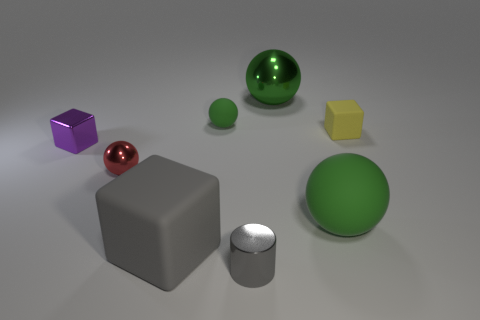Subtract all green spheres. How many were subtracted if there are2green spheres left? 1 Subtract all brown cylinders. How many green balls are left? 3 Add 1 small cylinders. How many objects exist? 9 Subtract all cubes. How many objects are left? 5 Add 6 green matte things. How many green matte things exist? 8 Subtract 0 red cubes. How many objects are left? 8 Subtract all small yellow metallic objects. Subtract all purple objects. How many objects are left? 7 Add 3 tiny purple blocks. How many tiny purple blocks are left? 4 